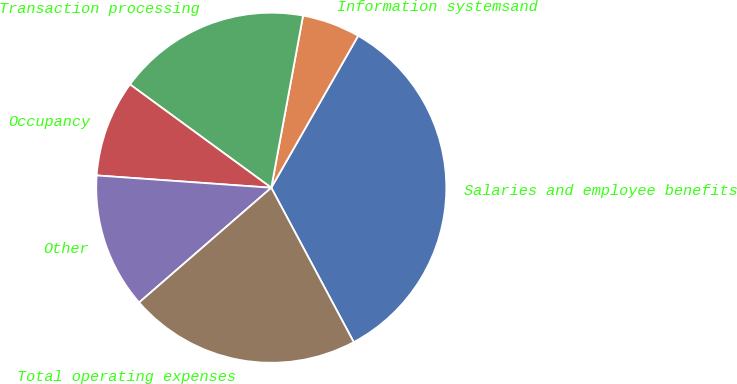Convert chart to OTSL. <chart><loc_0><loc_0><loc_500><loc_500><pie_chart><fcel>Salaries and employee benefits<fcel>Information systemsand<fcel>Transaction processing<fcel>Occupancy<fcel>Other<fcel>Total operating expenses<nl><fcel>33.93%<fcel>5.36%<fcel>17.86%<fcel>8.93%<fcel>12.5%<fcel>21.43%<nl></chart> 